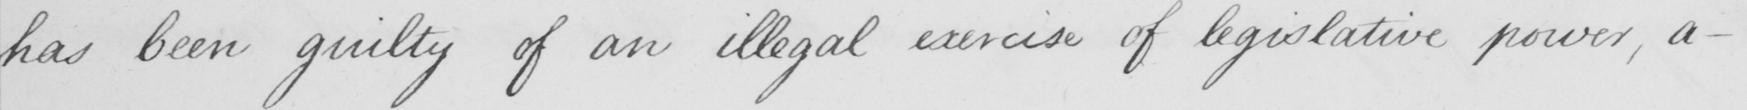What text is written in this handwritten line? has been guilty of an illegal exercise of legislative power , a- 